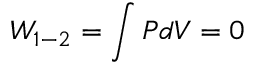Convert formula to latex. <formula><loc_0><loc_0><loc_500><loc_500>W _ { 1 - 2 } = \int P d V = 0</formula> 